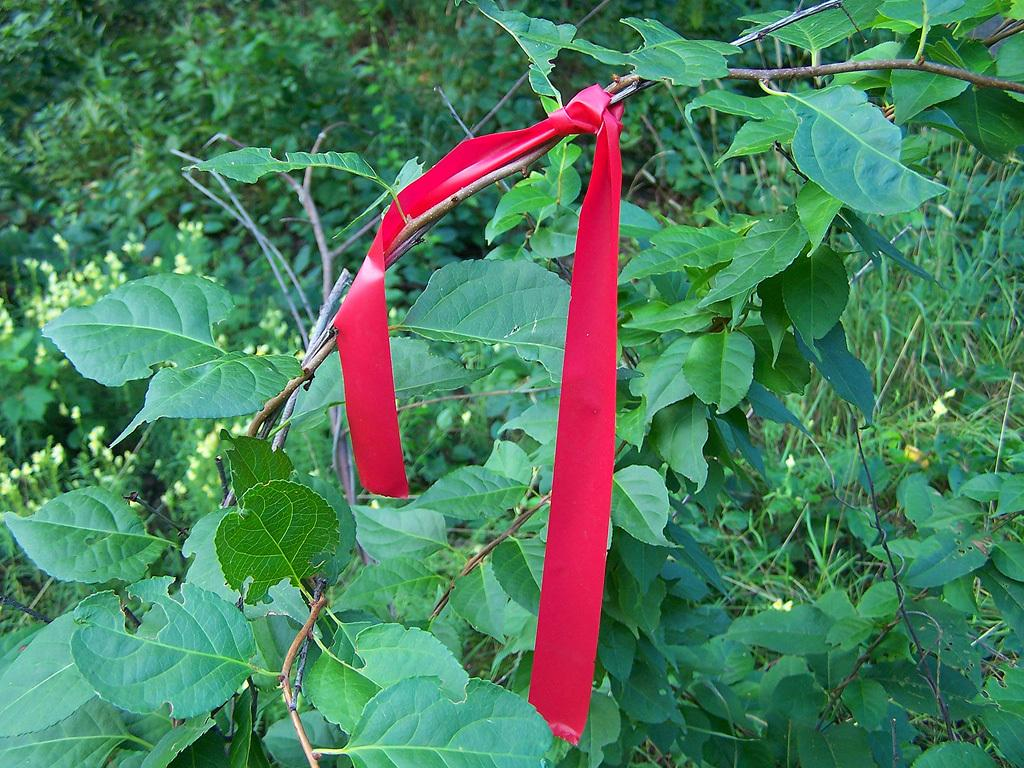What is the color of the ribbon tied to the plant in the picture? The ribbon tied to the plant in the picture is red. Where is the plant with the ribbon located in the picture? The plant with the ribbon is in the middle of the picture. What else can be seen in the background of the image? There are plants visible in the background of the image. What type of furniture is the son sitting on in the image? There is no son or furniture present in the image; it only features a plant with a red ribbon and other plants in the background. 